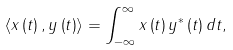Convert formula to latex. <formula><loc_0><loc_0><loc_500><loc_500>\left \langle x \left ( t \right ) , y \left ( t \right ) \right \rangle = \int _ { - \infty } ^ { \infty } x \left ( t \right ) y ^ { * } \left ( t \right ) d t ,</formula> 